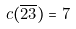Convert formula to latex. <formula><loc_0><loc_0><loc_500><loc_500>c ( \overline { 2 3 } ) = 7</formula> 